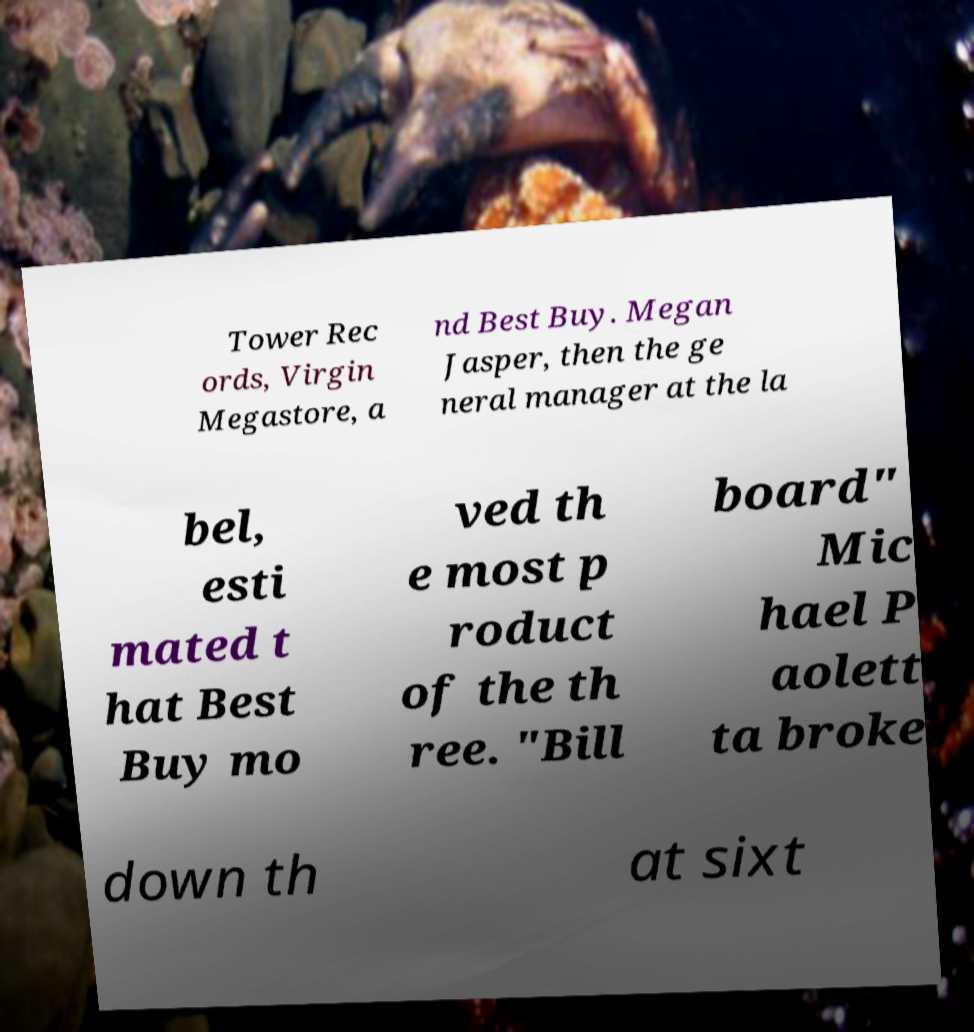Please identify and transcribe the text found in this image. Tower Rec ords, Virgin Megastore, a nd Best Buy. Megan Jasper, then the ge neral manager at the la bel, esti mated t hat Best Buy mo ved th e most p roduct of the th ree. "Bill board" Mic hael P aolett ta broke down th at sixt 